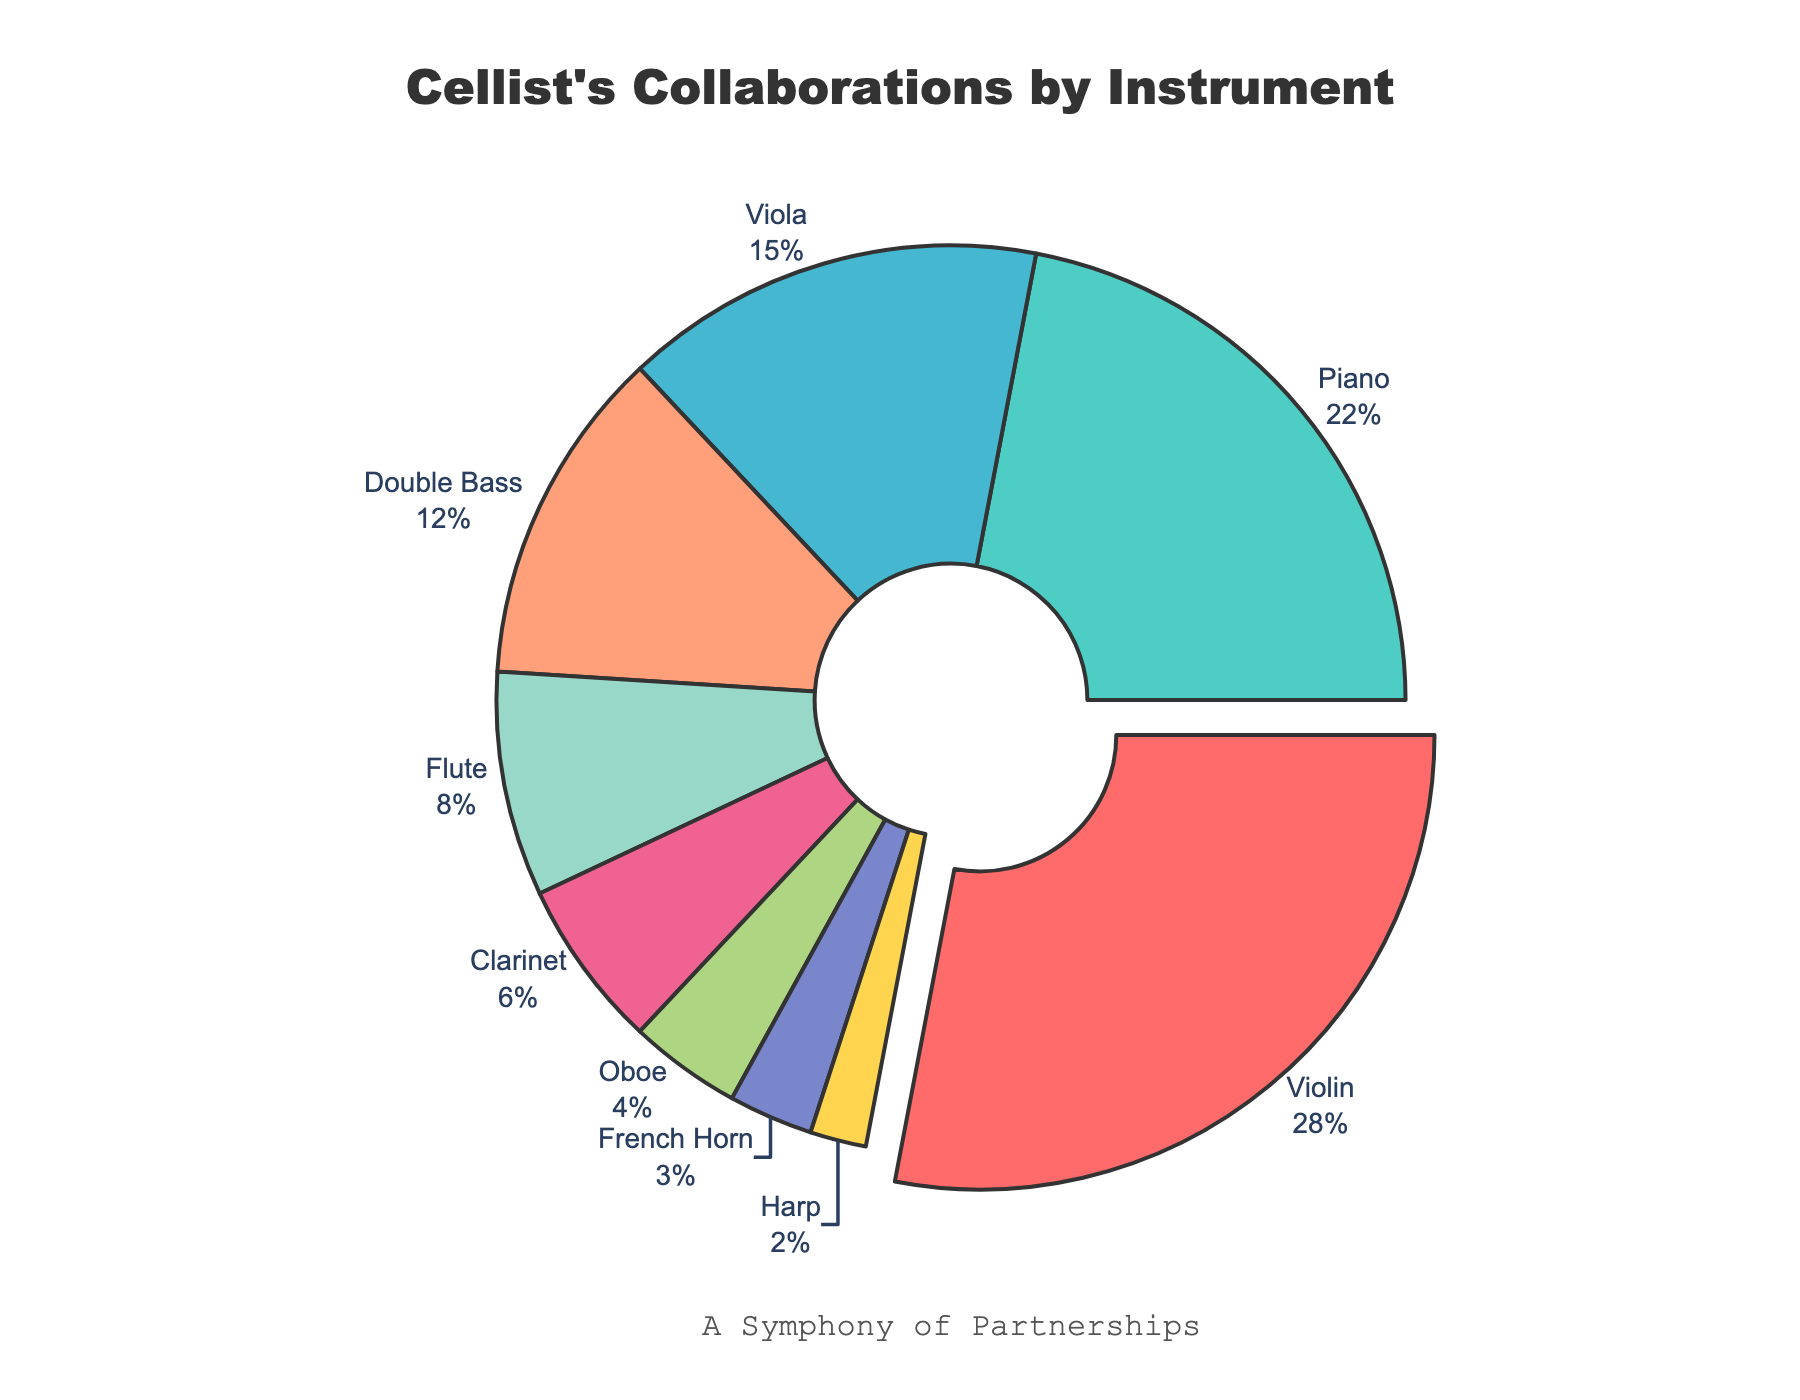Which instrument does the cellist collaborate with the most? By looking at the pie chart, the violin segment is pulled out and has the largest size, indicating the highest percentage of collaborations.
Answer: Violin Which instrument has a greater percentage of collaborations, the piano or the flute? The pie chart shows that the piano segment is larger than the flute segment, indicating a higher percentage for the piano.
Answer: Piano What is the combined percentage of collaborations with viola and double bass? By referring to the pie chart, we see the percentages: viola is 15% and double bass is 12%. Adding these together, 15% + 12% = 27%.
Answer: 27% Is the collaboration with the flute greater than or less than 10%? The flute segment is labeled 8%, which is less than 10%.
Answer: Less than 10% How much more frequently does the cellist collaborate with the violin compared to the oboe? The violin segment shows 28% and the oboe shows 4%. The difference is 28% - 4% = 24%.
Answer: 24% Which instrument has the smallest percentage of collaborations? The pie chart shows the smallest segment labeled 2%, which corresponds to the harp.
Answer: Harp Are the collaborations with the French horn closer in percentage to the harp or the oboe? The French horn has 3%, the harp has 2%, and the oboe has 4%. The difference between French horn and harp is 1%, while the difference between French horn and oboe is also 1%. Thus, they are equally close.
Answer: Equally close What is the average percentage of collaborations for piano, clarinet, and oboe? The percentages are 22% for piano, 6% for clarinet, and 4% for oboe. Adding these gives 22% + 6% + 4% = 32%. Dividing by 3 (number of instruments) gives 32% / 3 ≈ 10.67%.
Answer: 10.67% How does the cellist's collaboration with the double bass compare to that with the clarinet? The double bass segment shows 12% while the clarinet shows 6%. Thus, the cellist collaborates with the double bass twice as much as with the clarinet.
Answer: Double What percentage of collaborations are with wind instruments (flute, clarinet, oboe, French horn)? The percentages are: flute 8%, clarinet 6%, oboe 4%, French horn 3%. Adding these, we get 8% + 6% + 4% + 3% = 21%.
Answer: 21% 